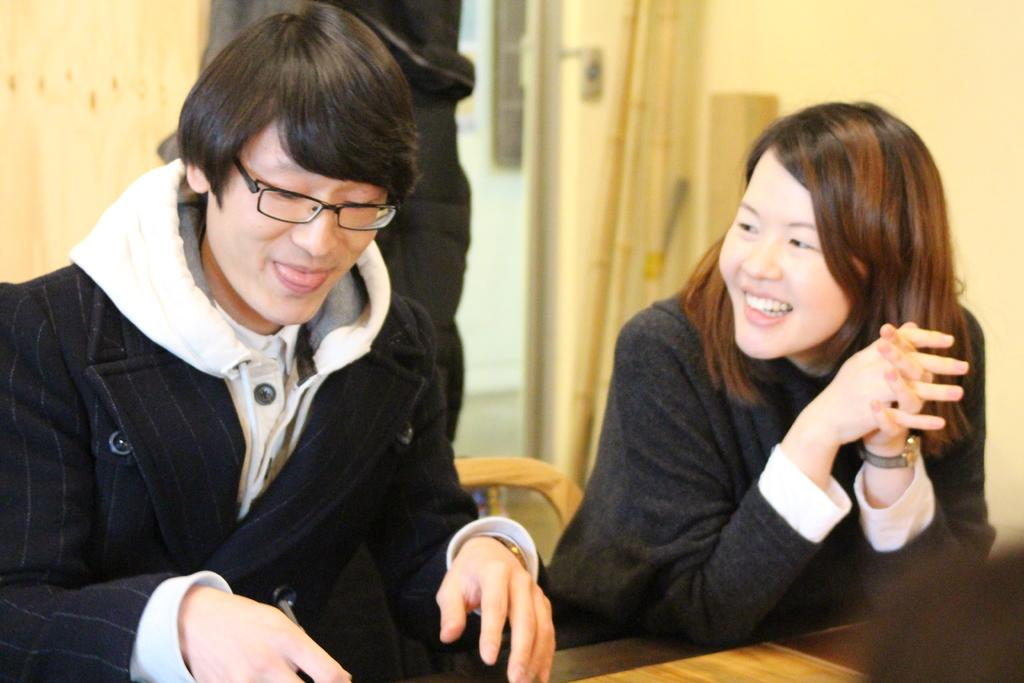How many people are present in the image? There are two people, a man and a woman, present in the image. What expressions do the man and woman have in the image? Both the man and the woman are smiling in the image. What is the primary piece of furniture in the image? There is a table in the image. Can you describe the background of the image? There is a wall in the background of the image, and there are other objects visible as well. What is the object in the image? There is an object in the image, but its specific nature cannot be determined from the provided facts. What song is the man and woman singing together in the image? There is no indication in the image that the man and woman are singing, nor is there any information about a song. 